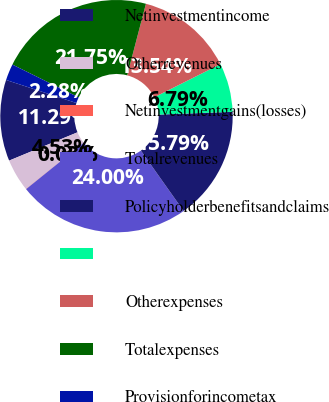<chart> <loc_0><loc_0><loc_500><loc_500><pie_chart><fcel>Netinvestmentincome<fcel>Otherrevenues<fcel>Netinvestmentgains(losses)<fcel>Totalrevenues<fcel>Policyholderbenefitsandclaims<fcel>Unnamed: 5<fcel>Otherexpenses<fcel>Totalexpenses<fcel>Provisionforincometax<nl><fcel>11.29%<fcel>4.53%<fcel>0.03%<fcel>24.0%<fcel>15.79%<fcel>6.79%<fcel>13.54%<fcel>21.75%<fcel>2.28%<nl></chart> 